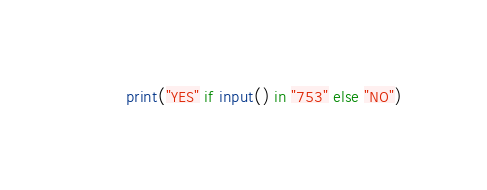Convert code to text. <code><loc_0><loc_0><loc_500><loc_500><_Python_>print("YES" if input() in "753" else "NO")</code> 